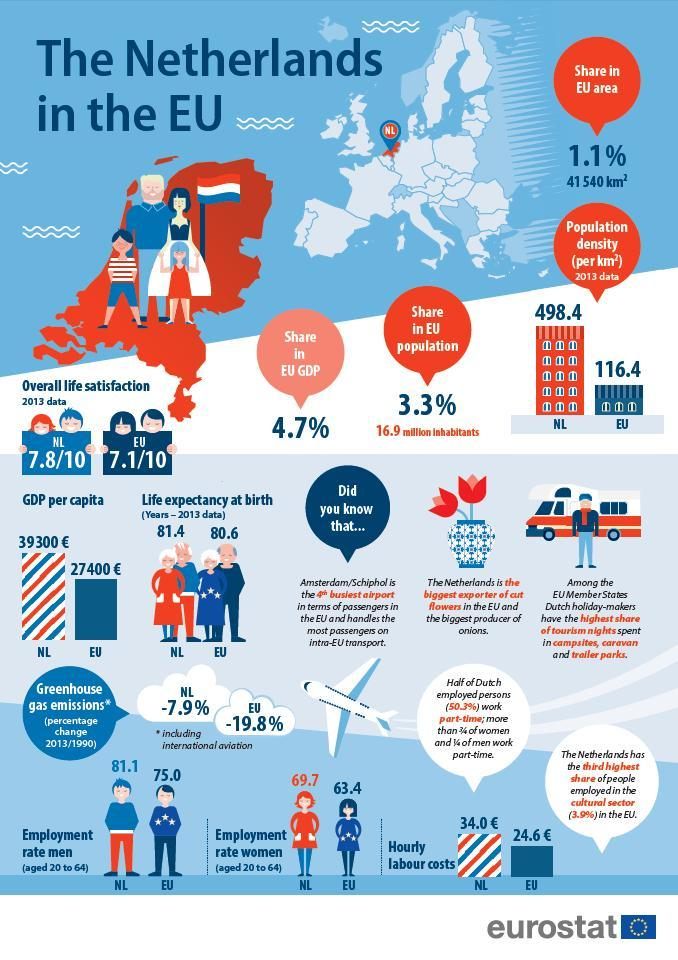which has more GDP per capita - Netherlands or overall EU?
Answer the question with a short phrase. Netherlands which has higher population density - Netherlands or overall EU? Netherlands which has more life expectancy at birth - Netherlands or overall EU? Netherlands which has lower rate of employability of men - Netherlands or overall EU? EU which has higher rate of women employability - Netherlands or overall EU? Netherlands 